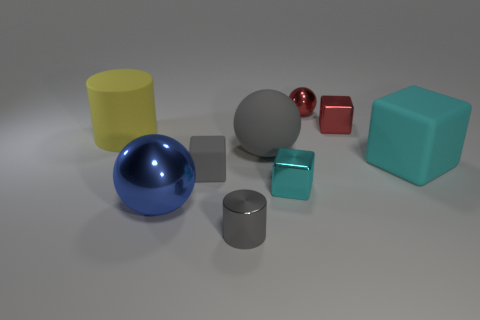What number of objects are small objects that are to the left of the small gray cylinder or balls right of the small cyan cube? Upon inspection of the image, there appears to be one small object to the left of the small gray cylinder and one ball to the right of the small cyan cube, which totals to two objects matching the description. 